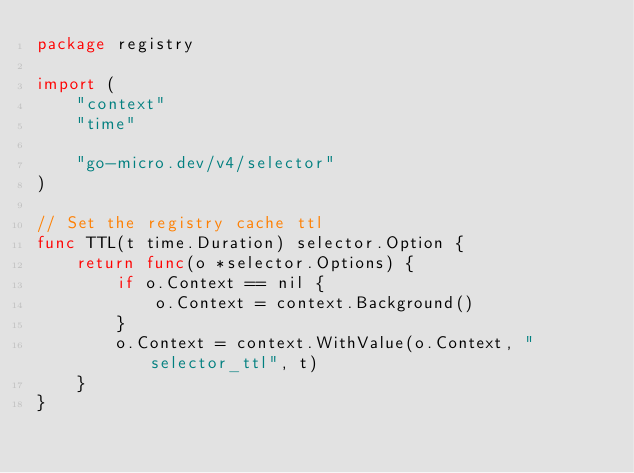<code> <loc_0><loc_0><loc_500><loc_500><_Go_>package registry

import (
	"context"
	"time"

	"go-micro.dev/v4/selector"
)

// Set the registry cache ttl
func TTL(t time.Duration) selector.Option {
	return func(o *selector.Options) {
		if o.Context == nil {
			o.Context = context.Background()
		}
		o.Context = context.WithValue(o.Context, "selector_ttl", t)
	}
}
</code> 